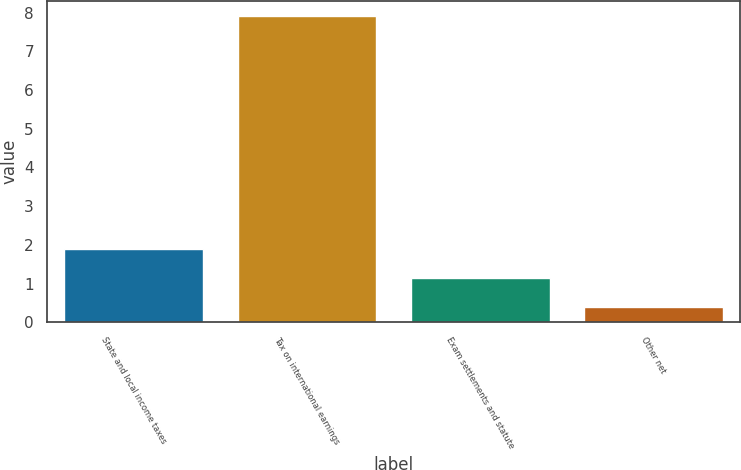Convert chart to OTSL. <chart><loc_0><loc_0><loc_500><loc_500><bar_chart><fcel>State and local income taxes<fcel>Tax on international earnings<fcel>Exam settlements and statute<fcel>Other net<nl><fcel>1.9<fcel>7.9<fcel>1.15<fcel>0.4<nl></chart> 